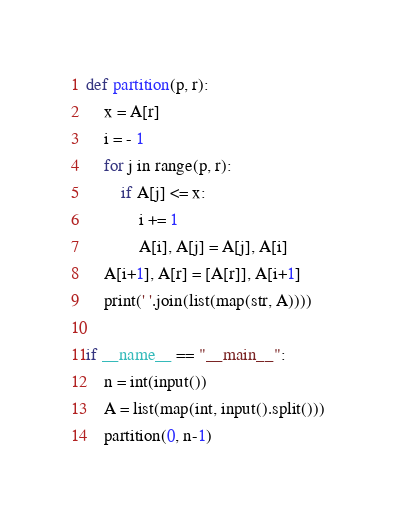<code> <loc_0><loc_0><loc_500><loc_500><_Python_>def partition(p, r):
    x = A[r]
    i = - 1
    for j in range(p, r):
        if A[j] <= x:
            i += 1
            A[i], A[j] = A[j], A[i]
    A[i+1], A[r] = [A[r]], A[i+1]
    print(' '.join(list(map(str, A))))

if __name__ == "__main__":
    n = int(input())
    A = list(map(int, input().split()))
    partition(0, n-1)
</code> 